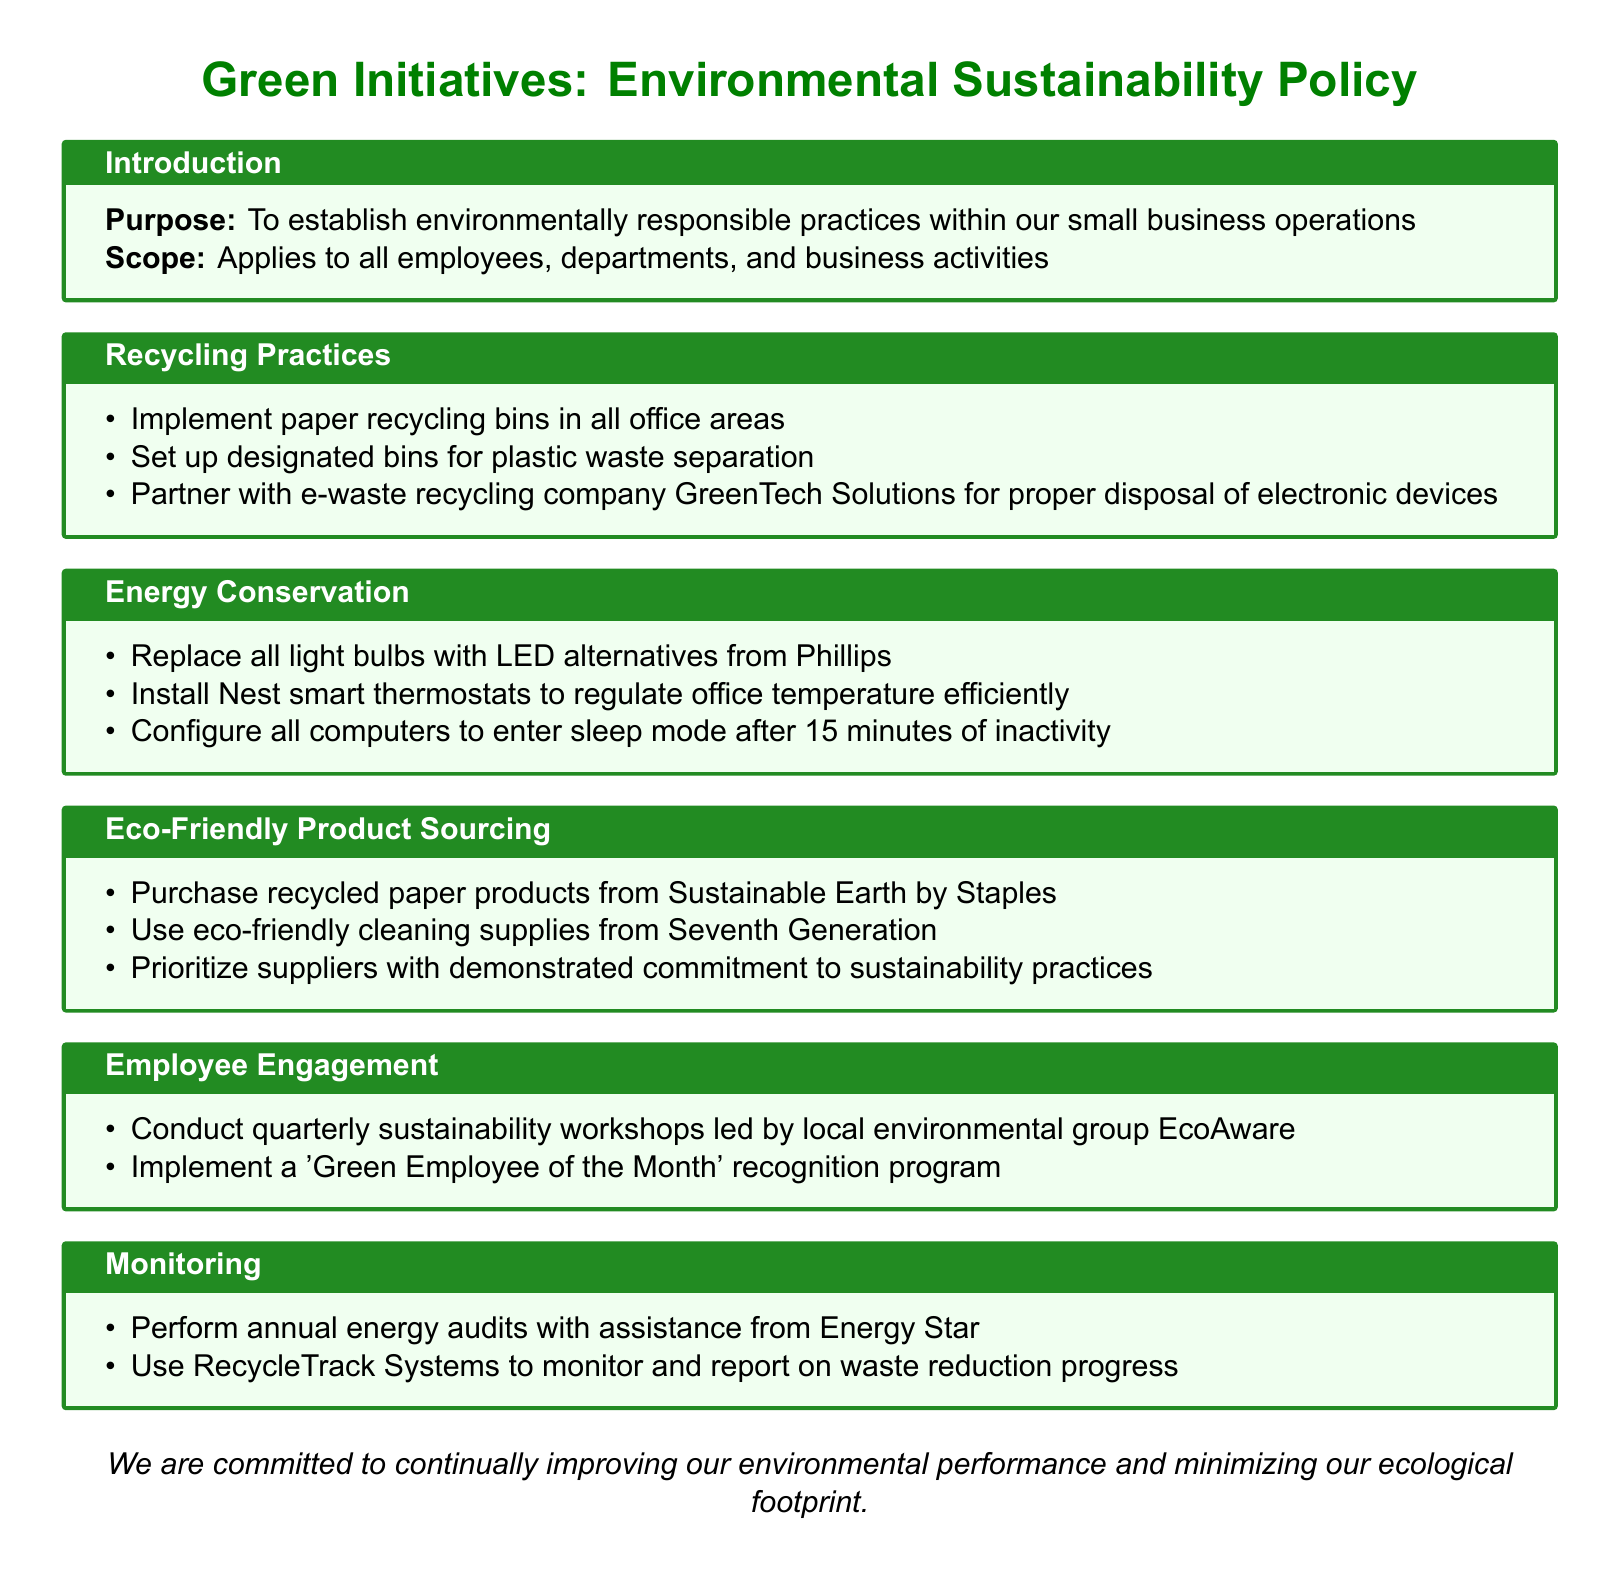What is the purpose of the policy? The purpose of the policy is to establish environmentally responsible practices within our small business operations.
Answer: environmentally responsible practices Who is responsible for conducting quarterly sustainability workshops? The workshops are led by local environmental group EcoAware.
Answer: EcoAware What type of light bulbs should be replaced according to the energy conservation section? The document specifies replacing all light bulbs with LED alternatives.
Answer: LED alternatives Which company is partnered with for e-waste recycling? The company partnered with for e-waste recycling is GreenTech Solutions.
Answer: GreenTech Solutions What product should be purchased from Sustainable Earth? Recycled paper products should be purchased from Sustainable Earth by Staples.
Answer: recycled paper products What recognition program is mentioned in the employee engagement section? The program mentioned is the 'Green Employee of the Month' recognition.
Answer: 'Green Employee of the Month' What is the frequency of the sustainability workshops? The workshops are conducted quarterly.
Answer: quarterly What type of audits are performed annually? Annual energy audits are performed.
Answer: energy audits Which brand of cleaning supplies is prioritized for eco-friendliness? The brand prioritized is Seventh Generation.
Answer: Seventh Generation 